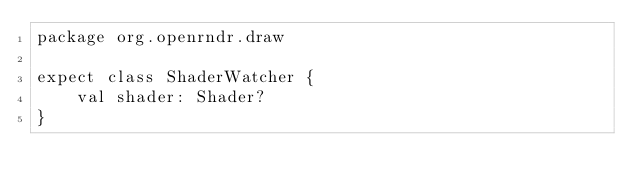<code> <loc_0><loc_0><loc_500><loc_500><_Kotlin_>package org.openrndr.draw

expect class ShaderWatcher {
    val shader: Shader?
}</code> 